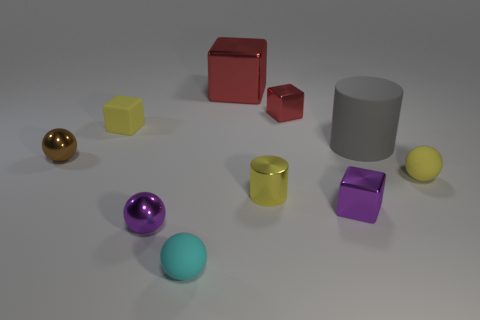Is the material of the small cyan sphere the same as the cylinder on the left side of the rubber cylinder?
Make the answer very short. No. There is a small ball that is the same color as the rubber cube; what is it made of?
Provide a short and direct response. Rubber. How many things are the same color as the rubber cylinder?
Make the answer very short. 0. How big is the brown sphere?
Give a very brief answer. Small. Does the big red object have the same shape as the matte thing in front of the tiny yellow rubber sphere?
Offer a very short reply. No. What color is the small block that is made of the same material as the large cylinder?
Provide a succinct answer. Yellow. What is the size of the yellow matte object that is on the left side of the cyan matte sphere?
Your answer should be compact. Small. Is the number of small purple blocks behind the gray matte object less than the number of red metallic things?
Your response must be concise. Yes. Do the rubber cylinder and the big metal block have the same color?
Your answer should be very brief. No. Are there any other things that are the same shape as the small red object?
Keep it short and to the point. Yes. 